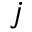Convert formula to latex. <formula><loc_0><loc_0><loc_500><loc_500>j</formula> 